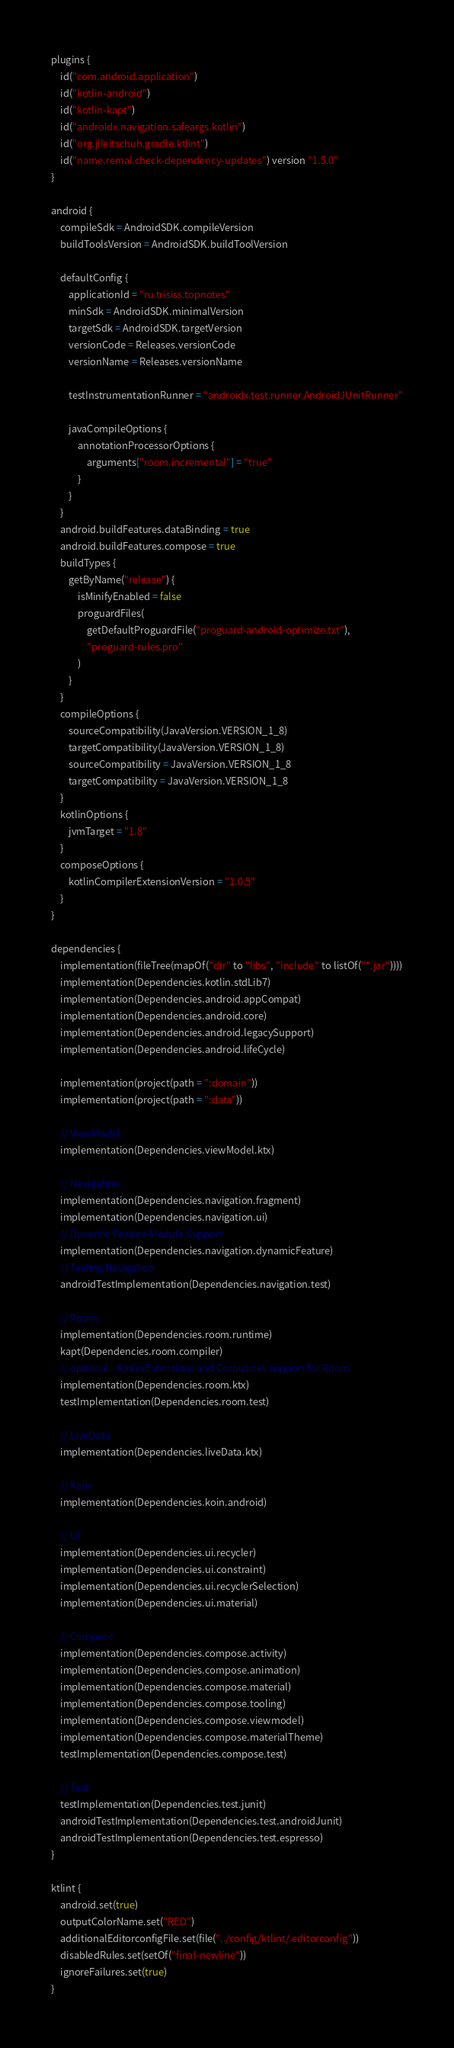<code> <loc_0><loc_0><loc_500><loc_500><_Kotlin_>plugins {
    id("com.android.application")
    id("kotlin-android")
    id("kotlin-kapt")
    id("androidx.navigation.safeargs.kotlin")
    id("org.jlleitschuh.gradle.ktlint")
    id("name.remal.check-dependency-updates") version "1.5.0"
}

android {
    compileSdk = AndroidSDK.compileVersion
    buildToolsVersion = AndroidSDK.buildToolVersion

    defaultConfig {
        applicationId = "ru.trisiss.topnotes"
        minSdk = AndroidSDK.minimalVersion
        targetSdk = AndroidSDK.targetVersion
        versionCode = Releases.versionCode
        versionName = Releases.versionName

        testInstrumentationRunner = "androidx.test.runner.AndroidJUnitRunner"

        javaCompileOptions {
            annotationProcessorOptions {
                arguments["room.incremental"] = "true"
            }
        }
    }
    android.buildFeatures.dataBinding = true
    android.buildFeatures.compose = true
    buildTypes {
        getByName("release") {
            isMinifyEnabled = false
            proguardFiles(
                getDefaultProguardFile("proguard-android-optimize.txt"),
                "proguard-rules.pro"
            )
        }
    }
    compileOptions {
        sourceCompatibility(JavaVersion.VERSION_1_8)
        targetCompatibility(JavaVersion.VERSION_1_8)
        sourceCompatibility = JavaVersion.VERSION_1_8
        targetCompatibility = JavaVersion.VERSION_1_8
    }
    kotlinOptions {
        jvmTarget = "1.8"
    }
    composeOptions {
        kotlinCompilerExtensionVersion = "1.0.5"
    }
}

dependencies {
    implementation(fileTree(mapOf("dir" to "libs", "include" to listOf("*.jar"))))
    implementation(Dependencies.kotlin.stdLib7)
    implementation(Dependencies.android.appCompat)
    implementation(Dependencies.android.core)
    implementation(Dependencies.android.legacySupport)
    implementation(Dependencies.android.lifeCycle)

    implementation(project(path = ":domain"))
    implementation(project(path = ":data"))

    // ViewModel
    implementation(Dependencies.viewModel.ktx)

    // Navigation
    implementation(Dependencies.navigation.fragment)
    implementation(Dependencies.navigation.ui)
    // Dynamic Feature Module Support
    implementation(Dependencies.navigation.dynamicFeature)
    // Testing Navigation
    androidTestImplementation(Dependencies.navigation.test)

    // Room
    implementation(Dependencies.room.runtime)
    kapt(Dependencies.room.compiler)
    // optional - Kotlin Extensions and Coroutines support for Room
    implementation(Dependencies.room.ktx)
    testImplementation(Dependencies.room.test)

    // LiveData
    implementation(Dependencies.liveData.ktx)

    // Koin
    implementation(Dependencies.koin.android)

    // UI
    implementation(Dependencies.ui.recycler)
    implementation(Dependencies.ui.constraint)
    implementation(Dependencies.ui.recyclerSelection)
    implementation(Dependencies.ui.material)

    // Compose
    implementation(Dependencies.compose.activity)
    implementation(Dependencies.compose.animation)
    implementation(Dependencies.compose.material)
    implementation(Dependencies.compose.tooling)
    implementation(Dependencies.compose.viewmodel)
    implementation(Dependencies.compose.materialTheme)
    testImplementation(Dependencies.compose.test)

    // Test
    testImplementation(Dependencies.test.junit)
    androidTestImplementation(Dependencies.test.androidJunit)
    androidTestImplementation(Dependencies.test.espresso)
}

ktlint {
    android.set(true)
    outputColorName.set("RED")
    additionalEditorconfigFile.set(file("../config/ktlint/.editorconfig"))
    disabledRules.set(setOf("final-newline"))
    ignoreFailures.set(true)
}
</code> 